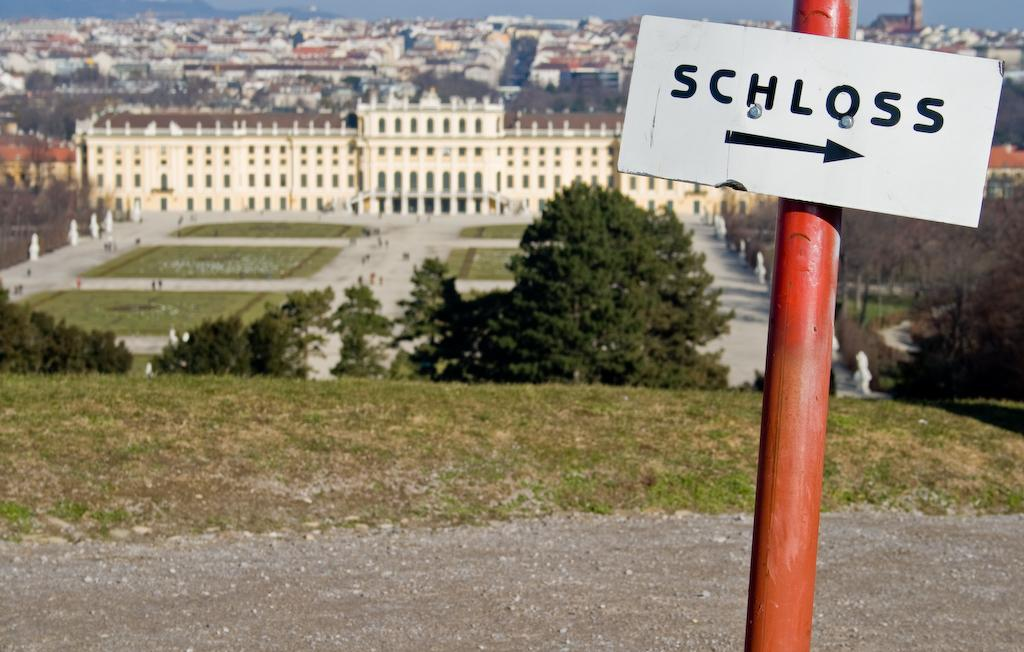<image>
Give a short and clear explanation of the subsequent image. A sign says Schloss and has an arrow pointing to the right. 